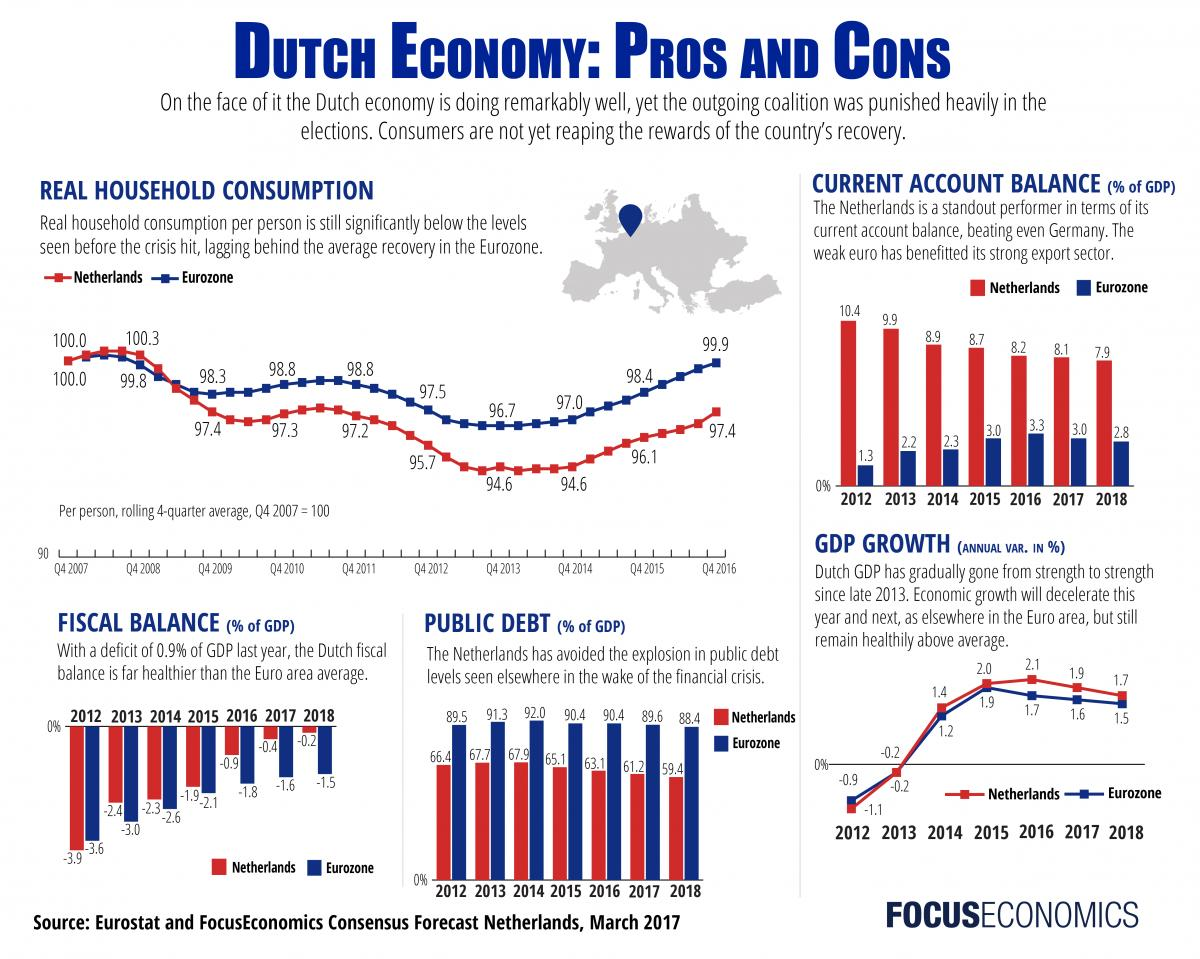Outline some significant characteristics in this image. In 2012, the fiscal balance in the Netherlands was -0.3, while the Eurozone as a whole had a fiscal deficit of 1.0. This means that the Netherlands had a smaller fiscal deficit than the Eurozone as a whole, indicating that the Dutch government was running a more fiscally responsible budget compared to other European countries. The current account balance in the Netherlands in 2012 was 9.1. In 2012, the public debt in the Eurozone was 23.1% while in the Netherlands it was 61.6%. 